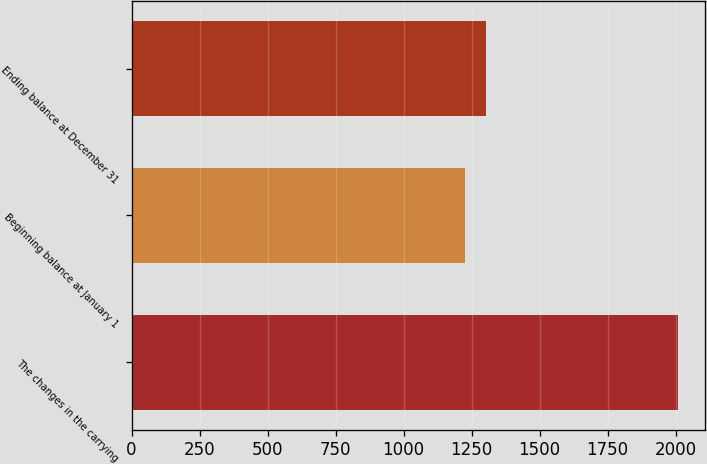Convert chart to OTSL. <chart><loc_0><loc_0><loc_500><loc_500><bar_chart><fcel>The changes in the carrying<fcel>Beginning balance at January 1<fcel>Ending balance at December 31<nl><fcel>2009<fcel>1225<fcel>1303.4<nl></chart> 